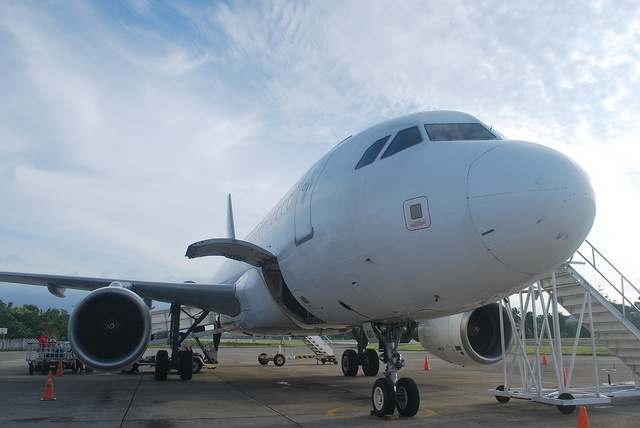Describe the objects in this image and their specific colors. I can see airplane in darkgray, gray, and black tones and people in darkgray, black, gray, maroon, and blue tones in this image. 